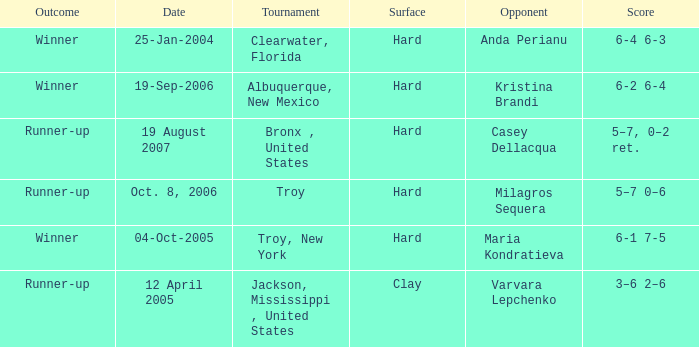What is the final score of the tournament played in Clearwater, Florida? 6-4 6-3. 